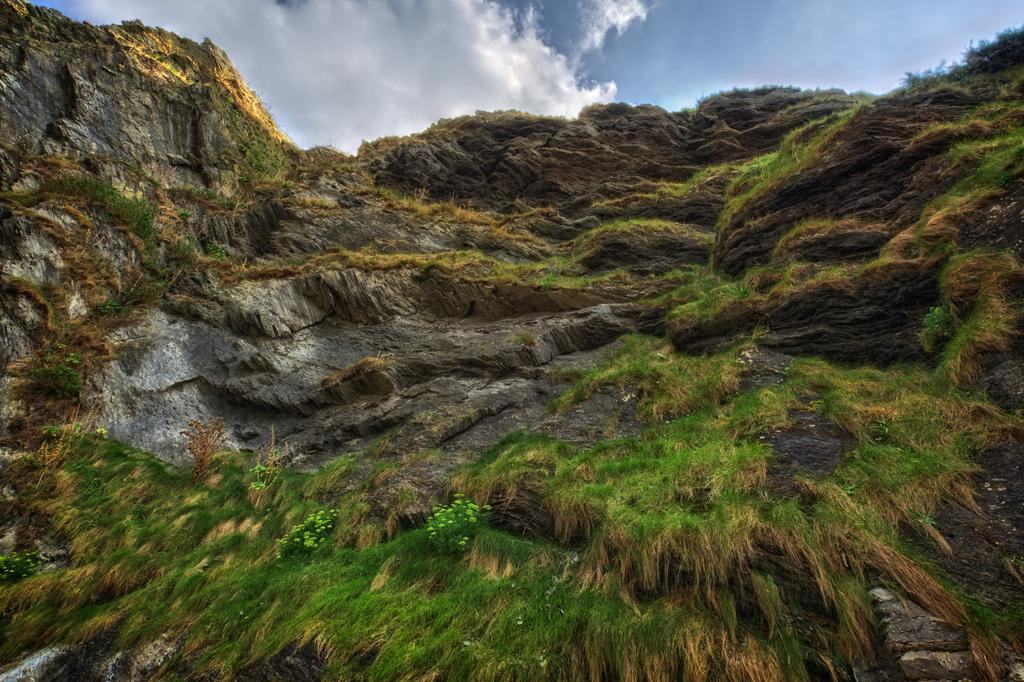What type of vegetation can be seen in the image? There is grass in the image. What geographical feature is present in the image? There is a hill in the image. What is visible in the background of the image? The sky is visible in the background of the image. What can be seen in the sky? Clouds are present in the sky. What impulse does the zebra have to cross the hill in the image? There is no zebra present in the image, so there is no impulse to consider. 